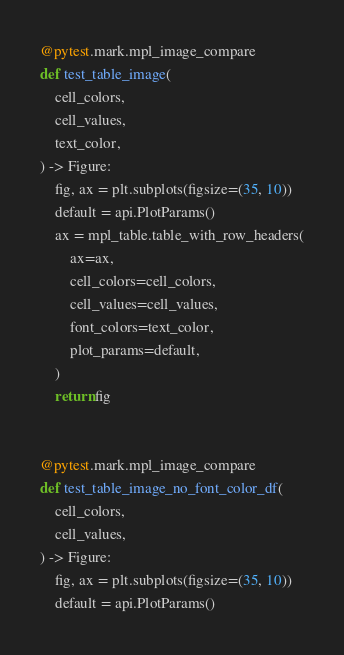Convert code to text. <code><loc_0><loc_0><loc_500><loc_500><_Python_>@pytest.mark.mpl_image_compare
def test_table_image(
    cell_colors,
    cell_values,
    text_color,
) -> Figure:
    fig, ax = plt.subplots(figsize=(35, 10))
    default = api.PlotParams()
    ax = mpl_table.table_with_row_headers(
        ax=ax,
        cell_colors=cell_colors,
        cell_values=cell_values,
        font_colors=text_color,
        plot_params=default,
    )
    return fig


@pytest.mark.mpl_image_compare
def test_table_image_no_font_color_df(
    cell_colors,
    cell_values,
) -> Figure:
    fig, ax = plt.subplots(figsize=(35, 10))
    default = api.PlotParams()</code> 